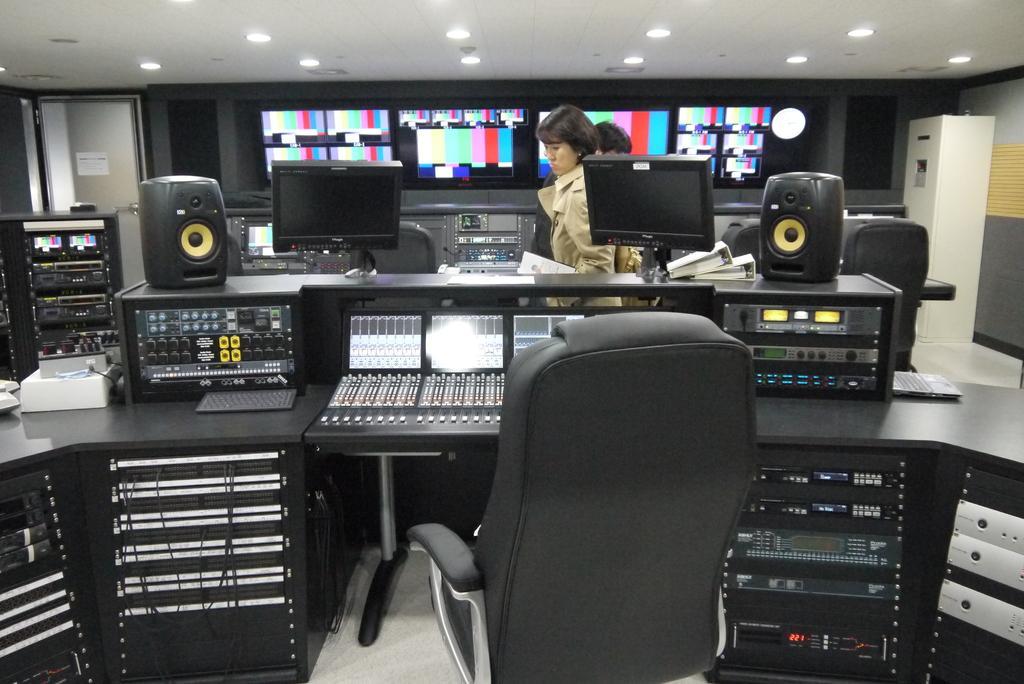In one or two sentences, can you explain what this image depicts? In this image we can see an electronics store. In the store we can see chair, speakers, display screens, electric lights, electric equipment, doors and lights attached to the roof. 